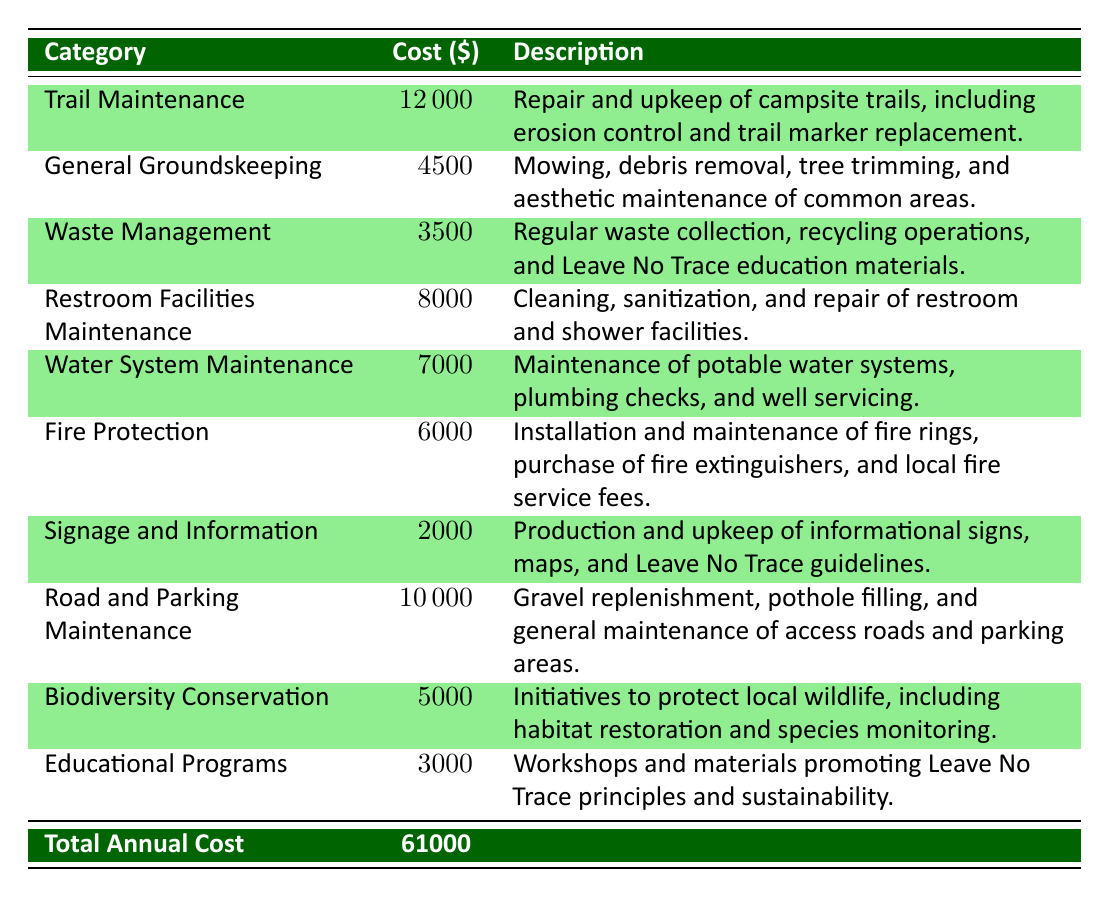What is the total annual cost for the Whispering Pines Campground? The total annual cost is listed at the bottom of the table under "Total Annual Cost," which shows a value of 61000.
Answer: 61000 What is the cost of trail maintenance? The cost of trail maintenance is specified in the category of "Trail Maintenance" and is listed as 12000.
Answer: 12000 How much is spent on waste management? The waste management cost can be found under the "Waste Management" category in the table, where it is indicated as 3500.
Answer: 3500 Is the cost of educational programs less than $5000? The educational programs cost is explicitly listed at 3000, which is less than 5000, making the statement true.
Answer: Yes Which category has the highest maintenance cost? To find the highest maintenance cost, we can compare all the category costs listed in the table. The highest cost is for "Trail Maintenance," which is 12000.
Answer: Trail Maintenance What is the total cost for restroom facilities and water system maintenance combined? To find the total of restroom facilities and water system maintenance, we add the costs for these categories: restroom facilities (8000) + water system (7000) = 15000.
Answer: 15000 What percentage of the total annual cost does general groundskeeping represent? The general groundskeeping cost is 4500. To find the percentage, we divide this by the total annual cost (61000) and multiply by 100: (4500 / 61000) * 100 ≈ 7.38%.
Answer: Approximately 7.38% Is there a category for biodiversity conservation? Yes, the table lists a category called "Biodiversity Conservation" and it shows a cost of 5000, confirming that such a category exists.
Answer: Yes What is the total cost associated with fire protection and signage combined? We add the costs of fire protection (6000) and signage (2000): 6000 + 2000 = 8000. This gives us the combined cost for these two categories.
Answer: 8000 